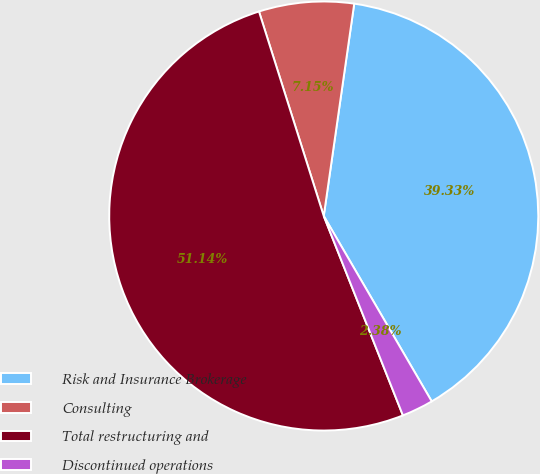Convert chart to OTSL. <chart><loc_0><loc_0><loc_500><loc_500><pie_chart><fcel>Risk and Insurance Brokerage<fcel>Consulting<fcel>Total restructuring and<fcel>Discontinued operations<nl><fcel>39.33%<fcel>7.15%<fcel>51.13%<fcel>2.38%<nl></chart> 